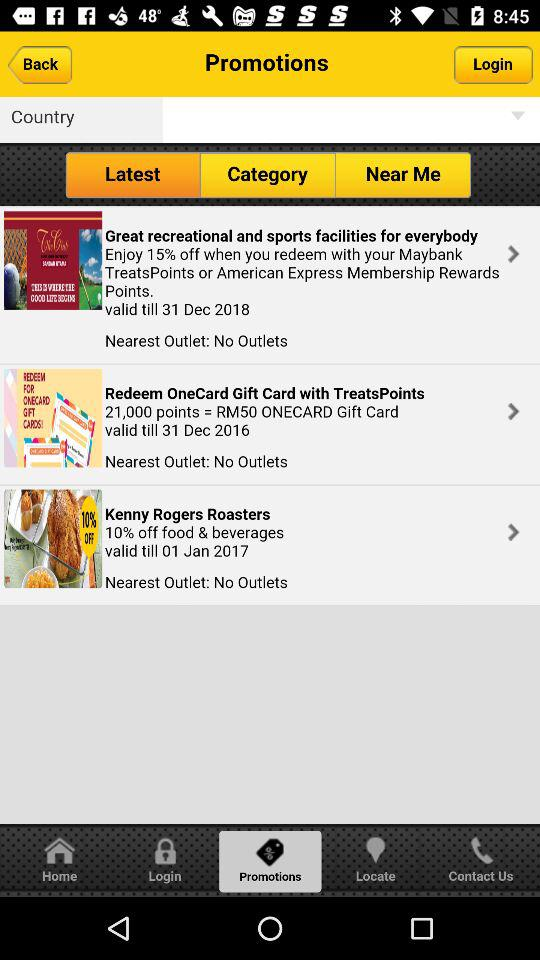How many promotions are there on this screen?
Answer the question using a single word or phrase. 3 